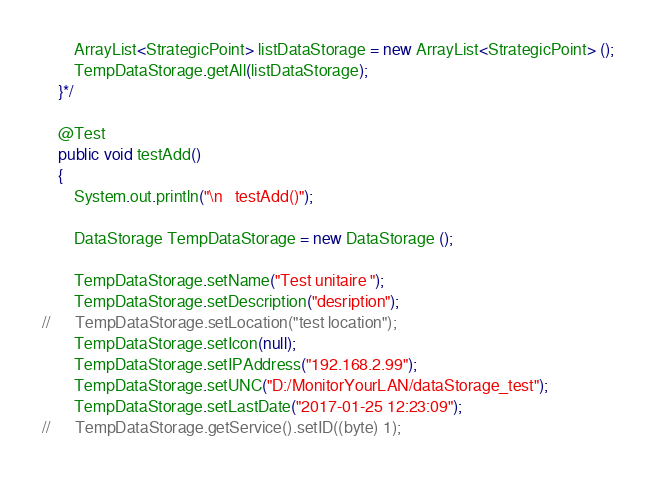Convert code to text. <code><loc_0><loc_0><loc_500><loc_500><_Java_>		ArrayList<StrategicPoint> listDataStorage = new ArrayList<StrategicPoint> ();
		TempDataStorage.getAll(listDataStorage);	
	}*/
	
	@Test
	public void testAdd()
	{
		System.out.println("\n   testAdd()");
		
		DataStorage TempDataStorage = new DataStorage ();	
		
		TempDataStorage.setName("Test unitaire ");
		TempDataStorage.setDescription("desription");
//		TempDataStorage.setLocation("test location");
		TempDataStorage.setIcon(null);
		TempDataStorage.setIPAddress("192.168.2.99");	
		TempDataStorage.setUNC("D:/MonitorYourLAN/dataStorage_test");
		TempDataStorage.setLastDate("2017-01-25 12:23:09");
//		TempDataStorage.getService().setID((byte) 1);
				</code> 